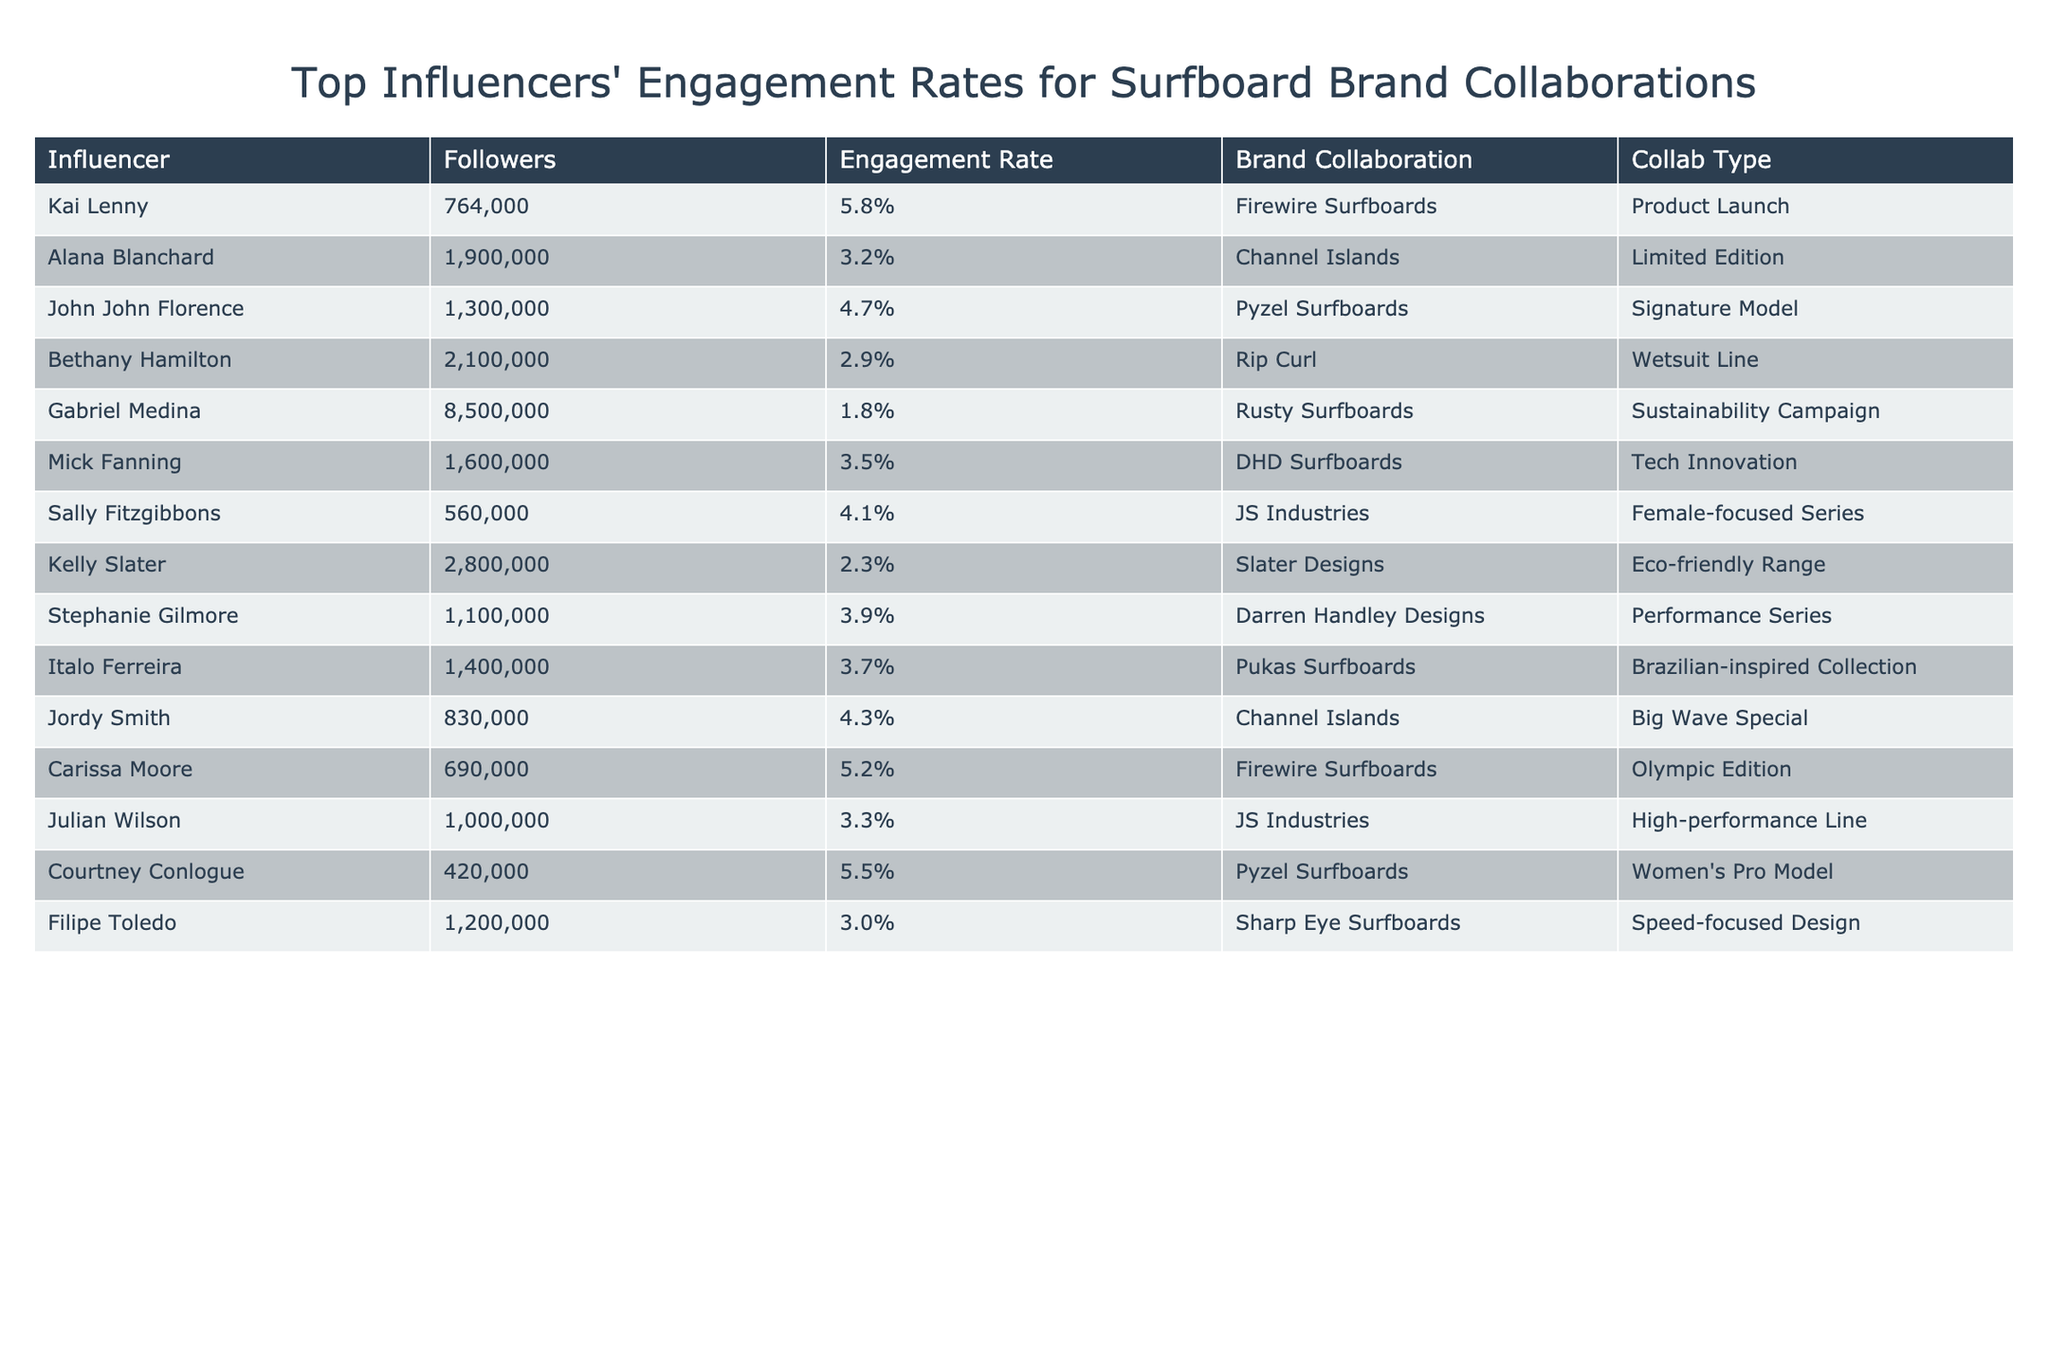What is the engagement rate of Alana Blanchard? The engagement rate is listed directly in the table under Alana Blanchard's entry, which shows a value of 3.2%.
Answer: 3.2% Which influencer has the highest number of followers? By comparing the Followers column, Gabriel Medina has the highest number with 8,500,000 followers.
Answer: Gabriel Medina What is the average engagement rate of influencers who collaborated on product launches? Summing the engagement rates of the product launch collaborations (5.8% + 5.2%) and dividing by the number of collaborations (2) gives an average of (5.8 + 5.2) / 2 = 5.5%.
Answer: 5.5% True or False: Kelly Slater collaborated on a sustainability campaign. By checking the Brand Collaboration for Kelly Slater, it shows he collaborated on an Eco-friendly Range, which is related to sustainability, thus the statement is true.
Answer: True Which influencer has the lowest engagement rate and what is that rate? Looking through the Engagement Rate column, it is clear that Gabriel Medina has the lowest rate at 1.8%.
Answer: Gabriel Medina, 1.8% How many influencers collaborated with JS Industries? Counting the rows in the table, there are two influencers, Mick Fanning and Julian Wilson, who collaborated with JS Industries.
Answer: 2 Which surfboard brand received collaborations from influencers with an engagement rate above 5%? By examining the Engagement Rate column, the brands Firewire Surfboards and Pyzel Surfboards received collaborations from influencers with rates above 5% (Kai Lenny, Carissa Moore, and Courtney Conlogue).
Answer: Firewire Surfboards, Pyzel Surfboards What is the total sum of followers for influencers with engagement rates above 4%? Adding the followers of influencers with engagement rates above 4% (Kai Lenny: 764,000 + John John Florence: 1,300,000 + Sally Fitzgibbons: 560,000 + Carissa Moore: 690,000 + Courtney Conlogue: 420,000 + Italo Ferreira: 1,400,000 + Jordy Smith: 830,000) gives a total of 5,654,000 followers.
Answer: 5,654,000 Which two influencers have engagement rates closest to each other? Comparing the engagement rates, Stephanie Gilmore (3.9%) and Italo Ferreira (3.7%) have the closest rates, with a difference of 0.2%.
Answer: Stephanie Gilmore, Italo Ferreira If an influencer has 1,200,000 followers, what is the likely range of their engagement rate based on the table? Analyzing the engagement rates of influencers with similar follower counts (Filipe Toledo: 3.0%, Julian Wilson: 3.3%), we can infer the engagement rate for an influencer with 1,200,000 followers is likely between 3.0% and 3.3%.
Answer: 3.0% to 3.3% 